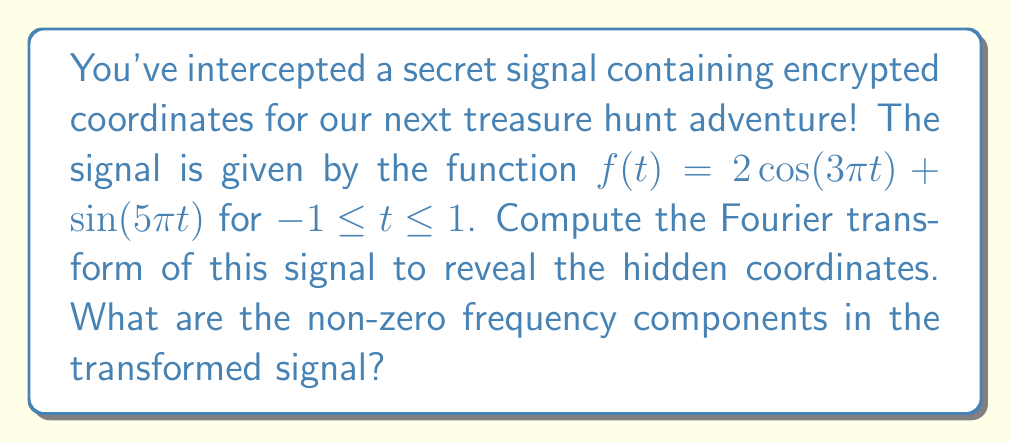Show me your answer to this math problem. Let's approach this step-by-step:

1) The Fourier transform of a function $f(t)$ is given by:

   $$F(\omega) = \int_{-\infty}^{\infty} f(t) e^{-i\omega t} dt$$

2) Our signal $f(t) = 2\cos(3\pi t) + \sin(5\pi t)$ is defined on $[-1,1]$, so we'll use this as our integration limits.

3) We can rewrite the cosine and sine functions using Euler's formula:

   $\cos(at) = \frac{e^{iat} + e^{-iat}}{2}$
   $\sin(at) = \frac{e^{iat} - e^{-iat}}{2i}$

4) Substituting these into our function:

   $f(t) = 2 \cdot \frac{e^{3\pi it} + e^{-3\pi it}}{2} + \frac{e^{5\pi it} - e^{-5\pi it}}{2i}$

5) Now, let's compute the Fourier transform:

   $$F(\omega) = \int_{-1}^{1} (e^{3\pi it} + e^{-3\pi it} + \frac{1}{2i}e^{5\pi it} - \frac{1}{2i}e^{-5\pi it}) e^{-i\omega t} dt$$

6) This gives us four integrals to solve:

   $$F(\omega) = \int_{-1}^{1} e^{i(3\pi-\omega)t} dt + \int_{-1}^{1} e^{-i(3\pi+\omega)t} dt + \frac{1}{2i}\int_{-1}^{1} e^{i(5\pi-\omega)t} dt - \frac{1}{2i}\int_{-1}^{1} e^{-i(5\pi+\omega)t} dt$$

7) The general solution for these integrals is:

   $$\int_{-1}^{1} e^{ixt} dt = \frac{2\sin(x)}{x}$$

8) Applying this to our four integrals:

   $$F(\omega) = \frac{2\sin(3\pi-\omega)}{3\pi-\omega} + \frac{2\sin(3\pi+\omega)}{3\pi+\omega} + \frac{1}{2i}\cdot\frac{2\sin(5\pi-\omega)}{5\pi-\omega} - \frac{1}{2i}\cdot\frac{2\sin(5\pi+\omega)}{5\pi+\omega}$$

9) The non-zero frequency components occur where the sinc functions ($\frac{\sin(x)}{x}$) have peaks. These peaks occur when the argument is zero.

10) Setting the arguments to zero:

    $3\pi-\omega = 0$ gives $\omega = 3\pi$
    $3\pi+\omega = 0$ gives $\omega = -3\pi$
    $5\pi-\omega = 0$ gives $\omega = 5\pi$
    $5\pi+\omega = 0$ gives $\omega = -5\pi$

Therefore, the non-zero frequency components are at $\omega = \pm 3\pi$ and $\omega = \pm 5\pi$.
Answer: $\pm 3\pi, \pm 5\pi$ 